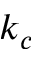<formula> <loc_0><loc_0><loc_500><loc_500>k _ { c }</formula> 